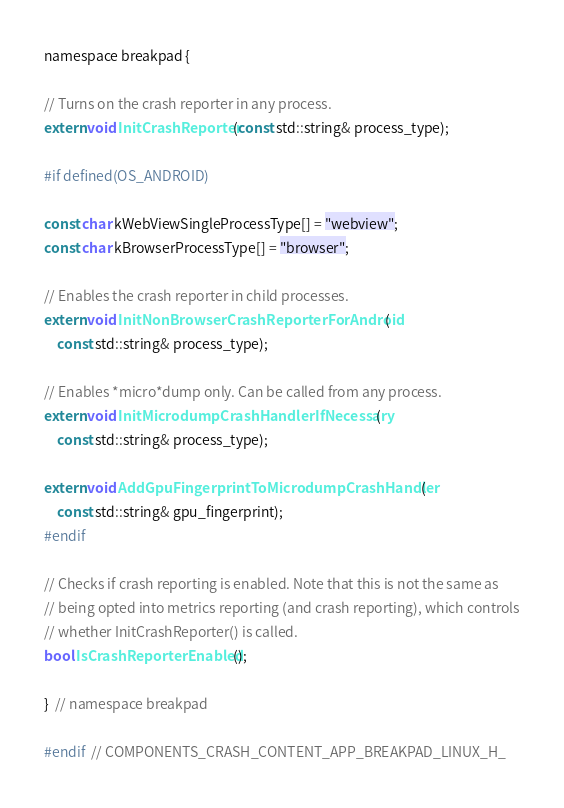<code> <loc_0><loc_0><loc_500><loc_500><_C_>namespace breakpad {

// Turns on the crash reporter in any process.
extern void InitCrashReporter(const std::string& process_type);

#if defined(OS_ANDROID)

const char kWebViewSingleProcessType[] = "webview";
const char kBrowserProcessType[] = "browser";

// Enables the crash reporter in child processes.
extern void InitNonBrowserCrashReporterForAndroid(
    const std::string& process_type);

// Enables *micro*dump only. Can be called from any process.
extern void InitMicrodumpCrashHandlerIfNecessary(
    const std::string& process_type);

extern void AddGpuFingerprintToMicrodumpCrashHandler(
    const std::string& gpu_fingerprint);
#endif

// Checks if crash reporting is enabled. Note that this is not the same as
// being opted into metrics reporting (and crash reporting), which controls
// whether InitCrashReporter() is called.
bool IsCrashReporterEnabled();

}  // namespace breakpad

#endif  // COMPONENTS_CRASH_CONTENT_APP_BREAKPAD_LINUX_H_
</code> 